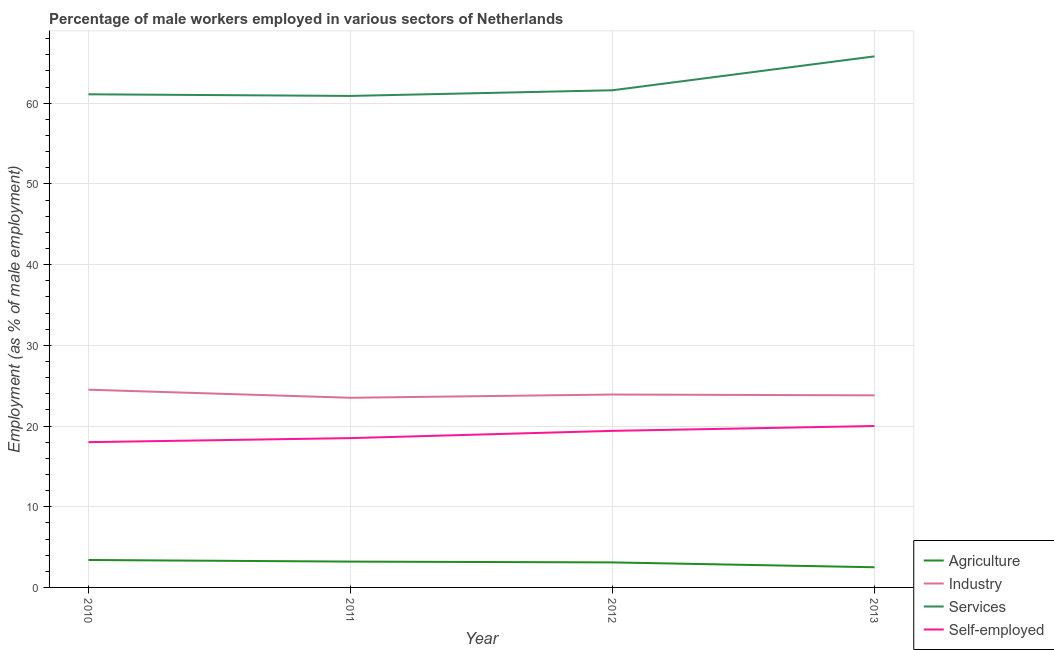How many different coloured lines are there?
Your response must be concise. 4. Does the line corresponding to percentage of male workers in agriculture intersect with the line corresponding to percentage of male workers in services?
Ensure brevity in your answer.  No. What is the percentage of male workers in industry in 2013?
Provide a succinct answer. 23.8. Across all years, what is the minimum percentage of male workers in industry?
Your answer should be compact. 23.5. In which year was the percentage of male workers in services minimum?
Keep it short and to the point. 2011. What is the total percentage of male workers in agriculture in the graph?
Provide a short and direct response. 12.2. What is the difference between the percentage of male workers in industry in 2010 and that in 2012?
Keep it short and to the point. 0.6. What is the difference between the percentage of self employed male workers in 2012 and the percentage of male workers in services in 2013?
Your answer should be compact. -46.4. What is the average percentage of male workers in services per year?
Your response must be concise. 62.35. What is the ratio of the percentage of male workers in industry in 2010 to that in 2013?
Your answer should be very brief. 1.03. Is the percentage of male workers in industry in 2010 less than that in 2011?
Provide a succinct answer. No. What is the difference between the highest and the second highest percentage of male workers in agriculture?
Offer a terse response. 0.2. What is the difference between the highest and the lowest percentage of male workers in industry?
Offer a very short reply. 1. Is the sum of the percentage of male workers in agriculture in 2012 and 2013 greater than the maximum percentage of self employed male workers across all years?
Make the answer very short. No. Is it the case that in every year, the sum of the percentage of male workers in agriculture and percentage of self employed male workers is greater than the sum of percentage of male workers in services and percentage of male workers in industry?
Provide a short and direct response. No. What is the difference between two consecutive major ticks on the Y-axis?
Your response must be concise. 10. Does the graph contain any zero values?
Offer a terse response. No. Does the graph contain grids?
Your answer should be very brief. Yes. What is the title of the graph?
Your answer should be compact. Percentage of male workers employed in various sectors of Netherlands. Does "Plant species" appear as one of the legend labels in the graph?
Your response must be concise. No. What is the label or title of the X-axis?
Offer a terse response. Year. What is the label or title of the Y-axis?
Keep it short and to the point. Employment (as % of male employment). What is the Employment (as % of male employment) in Agriculture in 2010?
Provide a short and direct response. 3.4. What is the Employment (as % of male employment) in Industry in 2010?
Make the answer very short. 24.5. What is the Employment (as % of male employment) in Services in 2010?
Ensure brevity in your answer.  61.1. What is the Employment (as % of male employment) in Agriculture in 2011?
Your response must be concise. 3.2. What is the Employment (as % of male employment) in Industry in 2011?
Your response must be concise. 23.5. What is the Employment (as % of male employment) in Services in 2011?
Give a very brief answer. 60.9. What is the Employment (as % of male employment) of Self-employed in 2011?
Provide a short and direct response. 18.5. What is the Employment (as % of male employment) of Agriculture in 2012?
Offer a very short reply. 3.1. What is the Employment (as % of male employment) in Industry in 2012?
Provide a succinct answer. 23.9. What is the Employment (as % of male employment) of Services in 2012?
Provide a short and direct response. 61.6. What is the Employment (as % of male employment) of Self-employed in 2012?
Offer a very short reply. 19.4. What is the Employment (as % of male employment) in Industry in 2013?
Ensure brevity in your answer.  23.8. What is the Employment (as % of male employment) in Services in 2013?
Offer a terse response. 65.8. Across all years, what is the maximum Employment (as % of male employment) of Agriculture?
Your answer should be very brief. 3.4. Across all years, what is the maximum Employment (as % of male employment) in Services?
Make the answer very short. 65.8. Across all years, what is the maximum Employment (as % of male employment) in Self-employed?
Give a very brief answer. 20. Across all years, what is the minimum Employment (as % of male employment) of Industry?
Make the answer very short. 23.5. Across all years, what is the minimum Employment (as % of male employment) of Services?
Make the answer very short. 60.9. What is the total Employment (as % of male employment) of Industry in the graph?
Keep it short and to the point. 95.7. What is the total Employment (as % of male employment) in Services in the graph?
Offer a terse response. 249.4. What is the total Employment (as % of male employment) in Self-employed in the graph?
Ensure brevity in your answer.  75.9. What is the difference between the Employment (as % of male employment) of Industry in 2010 and that in 2011?
Offer a very short reply. 1. What is the difference between the Employment (as % of male employment) in Self-employed in 2010 and that in 2011?
Ensure brevity in your answer.  -0.5. What is the difference between the Employment (as % of male employment) in Agriculture in 2010 and that in 2012?
Make the answer very short. 0.3. What is the difference between the Employment (as % of male employment) of Industry in 2010 and that in 2012?
Your response must be concise. 0.6. What is the difference between the Employment (as % of male employment) in Self-employed in 2010 and that in 2012?
Ensure brevity in your answer.  -1.4. What is the difference between the Employment (as % of male employment) in Agriculture in 2010 and that in 2013?
Give a very brief answer. 0.9. What is the difference between the Employment (as % of male employment) of Self-employed in 2010 and that in 2013?
Provide a short and direct response. -2. What is the difference between the Employment (as % of male employment) of Industry in 2011 and that in 2012?
Keep it short and to the point. -0.4. What is the difference between the Employment (as % of male employment) of Agriculture in 2012 and that in 2013?
Make the answer very short. 0.6. What is the difference between the Employment (as % of male employment) of Industry in 2012 and that in 2013?
Make the answer very short. 0.1. What is the difference between the Employment (as % of male employment) of Services in 2012 and that in 2013?
Make the answer very short. -4.2. What is the difference between the Employment (as % of male employment) of Agriculture in 2010 and the Employment (as % of male employment) of Industry in 2011?
Offer a terse response. -20.1. What is the difference between the Employment (as % of male employment) in Agriculture in 2010 and the Employment (as % of male employment) in Services in 2011?
Keep it short and to the point. -57.5. What is the difference between the Employment (as % of male employment) of Agriculture in 2010 and the Employment (as % of male employment) of Self-employed in 2011?
Offer a terse response. -15.1. What is the difference between the Employment (as % of male employment) of Industry in 2010 and the Employment (as % of male employment) of Services in 2011?
Give a very brief answer. -36.4. What is the difference between the Employment (as % of male employment) of Industry in 2010 and the Employment (as % of male employment) of Self-employed in 2011?
Provide a succinct answer. 6. What is the difference between the Employment (as % of male employment) of Services in 2010 and the Employment (as % of male employment) of Self-employed in 2011?
Make the answer very short. 42.6. What is the difference between the Employment (as % of male employment) in Agriculture in 2010 and the Employment (as % of male employment) in Industry in 2012?
Provide a succinct answer. -20.5. What is the difference between the Employment (as % of male employment) of Agriculture in 2010 and the Employment (as % of male employment) of Services in 2012?
Keep it short and to the point. -58.2. What is the difference between the Employment (as % of male employment) of Agriculture in 2010 and the Employment (as % of male employment) of Self-employed in 2012?
Provide a succinct answer. -16. What is the difference between the Employment (as % of male employment) of Industry in 2010 and the Employment (as % of male employment) of Services in 2012?
Ensure brevity in your answer.  -37.1. What is the difference between the Employment (as % of male employment) of Industry in 2010 and the Employment (as % of male employment) of Self-employed in 2012?
Your answer should be very brief. 5.1. What is the difference between the Employment (as % of male employment) in Services in 2010 and the Employment (as % of male employment) in Self-employed in 2012?
Give a very brief answer. 41.7. What is the difference between the Employment (as % of male employment) of Agriculture in 2010 and the Employment (as % of male employment) of Industry in 2013?
Give a very brief answer. -20.4. What is the difference between the Employment (as % of male employment) in Agriculture in 2010 and the Employment (as % of male employment) in Services in 2013?
Provide a short and direct response. -62.4. What is the difference between the Employment (as % of male employment) of Agriculture in 2010 and the Employment (as % of male employment) of Self-employed in 2013?
Your answer should be very brief. -16.6. What is the difference between the Employment (as % of male employment) of Industry in 2010 and the Employment (as % of male employment) of Services in 2013?
Your answer should be very brief. -41.3. What is the difference between the Employment (as % of male employment) in Industry in 2010 and the Employment (as % of male employment) in Self-employed in 2013?
Your answer should be very brief. 4.5. What is the difference between the Employment (as % of male employment) of Services in 2010 and the Employment (as % of male employment) of Self-employed in 2013?
Your response must be concise. 41.1. What is the difference between the Employment (as % of male employment) in Agriculture in 2011 and the Employment (as % of male employment) in Industry in 2012?
Keep it short and to the point. -20.7. What is the difference between the Employment (as % of male employment) in Agriculture in 2011 and the Employment (as % of male employment) in Services in 2012?
Provide a short and direct response. -58.4. What is the difference between the Employment (as % of male employment) in Agriculture in 2011 and the Employment (as % of male employment) in Self-employed in 2012?
Ensure brevity in your answer.  -16.2. What is the difference between the Employment (as % of male employment) of Industry in 2011 and the Employment (as % of male employment) of Services in 2012?
Ensure brevity in your answer.  -38.1. What is the difference between the Employment (as % of male employment) of Services in 2011 and the Employment (as % of male employment) of Self-employed in 2012?
Make the answer very short. 41.5. What is the difference between the Employment (as % of male employment) of Agriculture in 2011 and the Employment (as % of male employment) of Industry in 2013?
Offer a terse response. -20.6. What is the difference between the Employment (as % of male employment) in Agriculture in 2011 and the Employment (as % of male employment) in Services in 2013?
Provide a succinct answer. -62.6. What is the difference between the Employment (as % of male employment) of Agriculture in 2011 and the Employment (as % of male employment) of Self-employed in 2013?
Give a very brief answer. -16.8. What is the difference between the Employment (as % of male employment) of Industry in 2011 and the Employment (as % of male employment) of Services in 2013?
Keep it short and to the point. -42.3. What is the difference between the Employment (as % of male employment) of Services in 2011 and the Employment (as % of male employment) of Self-employed in 2013?
Make the answer very short. 40.9. What is the difference between the Employment (as % of male employment) of Agriculture in 2012 and the Employment (as % of male employment) of Industry in 2013?
Make the answer very short. -20.7. What is the difference between the Employment (as % of male employment) of Agriculture in 2012 and the Employment (as % of male employment) of Services in 2013?
Make the answer very short. -62.7. What is the difference between the Employment (as % of male employment) in Agriculture in 2012 and the Employment (as % of male employment) in Self-employed in 2013?
Your response must be concise. -16.9. What is the difference between the Employment (as % of male employment) of Industry in 2012 and the Employment (as % of male employment) of Services in 2013?
Provide a short and direct response. -41.9. What is the difference between the Employment (as % of male employment) in Industry in 2012 and the Employment (as % of male employment) in Self-employed in 2013?
Your answer should be compact. 3.9. What is the difference between the Employment (as % of male employment) of Services in 2012 and the Employment (as % of male employment) of Self-employed in 2013?
Your answer should be very brief. 41.6. What is the average Employment (as % of male employment) in Agriculture per year?
Offer a terse response. 3.05. What is the average Employment (as % of male employment) in Industry per year?
Keep it short and to the point. 23.93. What is the average Employment (as % of male employment) in Services per year?
Give a very brief answer. 62.35. What is the average Employment (as % of male employment) in Self-employed per year?
Provide a short and direct response. 18.98. In the year 2010, what is the difference between the Employment (as % of male employment) of Agriculture and Employment (as % of male employment) of Industry?
Offer a terse response. -21.1. In the year 2010, what is the difference between the Employment (as % of male employment) of Agriculture and Employment (as % of male employment) of Services?
Give a very brief answer. -57.7. In the year 2010, what is the difference between the Employment (as % of male employment) in Agriculture and Employment (as % of male employment) in Self-employed?
Your answer should be very brief. -14.6. In the year 2010, what is the difference between the Employment (as % of male employment) in Industry and Employment (as % of male employment) in Services?
Offer a terse response. -36.6. In the year 2010, what is the difference between the Employment (as % of male employment) in Industry and Employment (as % of male employment) in Self-employed?
Give a very brief answer. 6.5. In the year 2010, what is the difference between the Employment (as % of male employment) in Services and Employment (as % of male employment) in Self-employed?
Offer a very short reply. 43.1. In the year 2011, what is the difference between the Employment (as % of male employment) of Agriculture and Employment (as % of male employment) of Industry?
Make the answer very short. -20.3. In the year 2011, what is the difference between the Employment (as % of male employment) in Agriculture and Employment (as % of male employment) in Services?
Give a very brief answer. -57.7. In the year 2011, what is the difference between the Employment (as % of male employment) in Agriculture and Employment (as % of male employment) in Self-employed?
Your answer should be very brief. -15.3. In the year 2011, what is the difference between the Employment (as % of male employment) in Industry and Employment (as % of male employment) in Services?
Offer a very short reply. -37.4. In the year 2011, what is the difference between the Employment (as % of male employment) of Services and Employment (as % of male employment) of Self-employed?
Offer a terse response. 42.4. In the year 2012, what is the difference between the Employment (as % of male employment) of Agriculture and Employment (as % of male employment) of Industry?
Your answer should be very brief. -20.8. In the year 2012, what is the difference between the Employment (as % of male employment) of Agriculture and Employment (as % of male employment) of Services?
Your response must be concise. -58.5. In the year 2012, what is the difference between the Employment (as % of male employment) of Agriculture and Employment (as % of male employment) of Self-employed?
Offer a very short reply. -16.3. In the year 2012, what is the difference between the Employment (as % of male employment) in Industry and Employment (as % of male employment) in Services?
Your answer should be very brief. -37.7. In the year 2012, what is the difference between the Employment (as % of male employment) of Services and Employment (as % of male employment) of Self-employed?
Offer a very short reply. 42.2. In the year 2013, what is the difference between the Employment (as % of male employment) of Agriculture and Employment (as % of male employment) of Industry?
Provide a succinct answer. -21.3. In the year 2013, what is the difference between the Employment (as % of male employment) in Agriculture and Employment (as % of male employment) in Services?
Offer a terse response. -63.3. In the year 2013, what is the difference between the Employment (as % of male employment) of Agriculture and Employment (as % of male employment) of Self-employed?
Offer a terse response. -17.5. In the year 2013, what is the difference between the Employment (as % of male employment) of Industry and Employment (as % of male employment) of Services?
Your answer should be compact. -42. In the year 2013, what is the difference between the Employment (as % of male employment) of Services and Employment (as % of male employment) of Self-employed?
Provide a short and direct response. 45.8. What is the ratio of the Employment (as % of male employment) in Industry in 2010 to that in 2011?
Offer a terse response. 1.04. What is the ratio of the Employment (as % of male employment) of Agriculture in 2010 to that in 2012?
Offer a very short reply. 1.1. What is the ratio of the Employment (as % of male employment) of Industry in 2010 to that in 2012?
Your answer should be compact. 1.03. What is the ratio of the Employment (as % of male employment) in Self-employed in 2010 to that in 2012?
Offer a terse response. 0.93. What is the ratio of the Employment (as % of male employment) of Agriculture in 2010 to that in 2013?
Provide a short and direct response. 1.36. What is the ratio of the Employment (as % of male employment) in Industry in 2010 to that in 2013?
Provide a short and direct response. 1.03. What is the ratio of the Employment (as % of male employment) in Agriculture in 2011 to that in 2012?
Your response must be concise. 1.03. What is the ratio of the Employment (as % of male employment) in Industry in 2011 to that in 2012?
Provide a short and direct response. 0.98. What is the ratio of the Employment (as % of male employment) of Self-employed in 2011 to that in 2012?
Give a very brief answer. 0.95. What is the ratio of the Employment (as % of male employment) of Agriculture in 2011 to that in 2013?
Make the answer very short. 1.28. What is the ratio of the Employment (as % of male employment) of Industry in 2011 to that in 2013?
Your answer should be very brief. 0.99. What is the ratio of the Employment (as % of male employment) of Services in 2011 to that in 2013?
Your response must be concise. 0.93. What is the ratio of the Employment (as % of male employment) in Self-employed in 2011 to that in 2013?
Provide a short and direct response. 0.93. What is the ratio of the Employment (as % of male employment) of Agriculture in 2012 to that in 2013?
Keep it short and to the point. 1.24. What is the ratio of the Employment (as % of male employment) of Services in 2012 to that in 2013?
Make the answer very short. 0.94. What is the difference between the highest and the second highest Employment (as % of male employment) in Agriculture?
Offer a terse response. 0.2. What is the difference between the highest and the lowest Employment (as % of male employment) of Agriculture?
Your answer should be compact. 0.9. What is the difference between the highest and the lowest Employment (as % of male employment) of Industry?
Your answer should be very brief. 1. What is the difference between the highest and the lowest Employment (as % of male employment) of Services?
Keep it short and to the point. 4.9. What is the difference between the highest and the lowest Employment (as % of male employment) of Self-employed?
Offer a terse response. 2. 